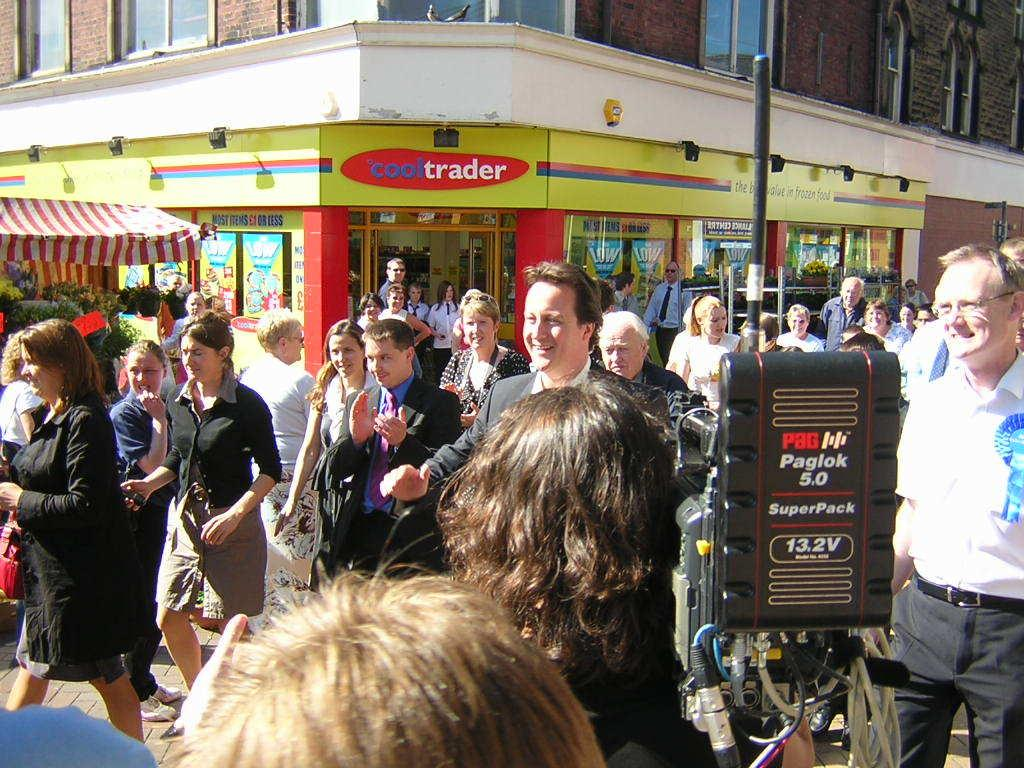Who or what can be seen in the image? There are people in the image. What is on the pole in the image? There is an electrical device on a pole. What can be seen in the distance in the image? There is a building, windows, a tent, and posters visible in the background. How do the ducks move around in the image? There are no ducks present in the image, so their movement cannot be observed. 